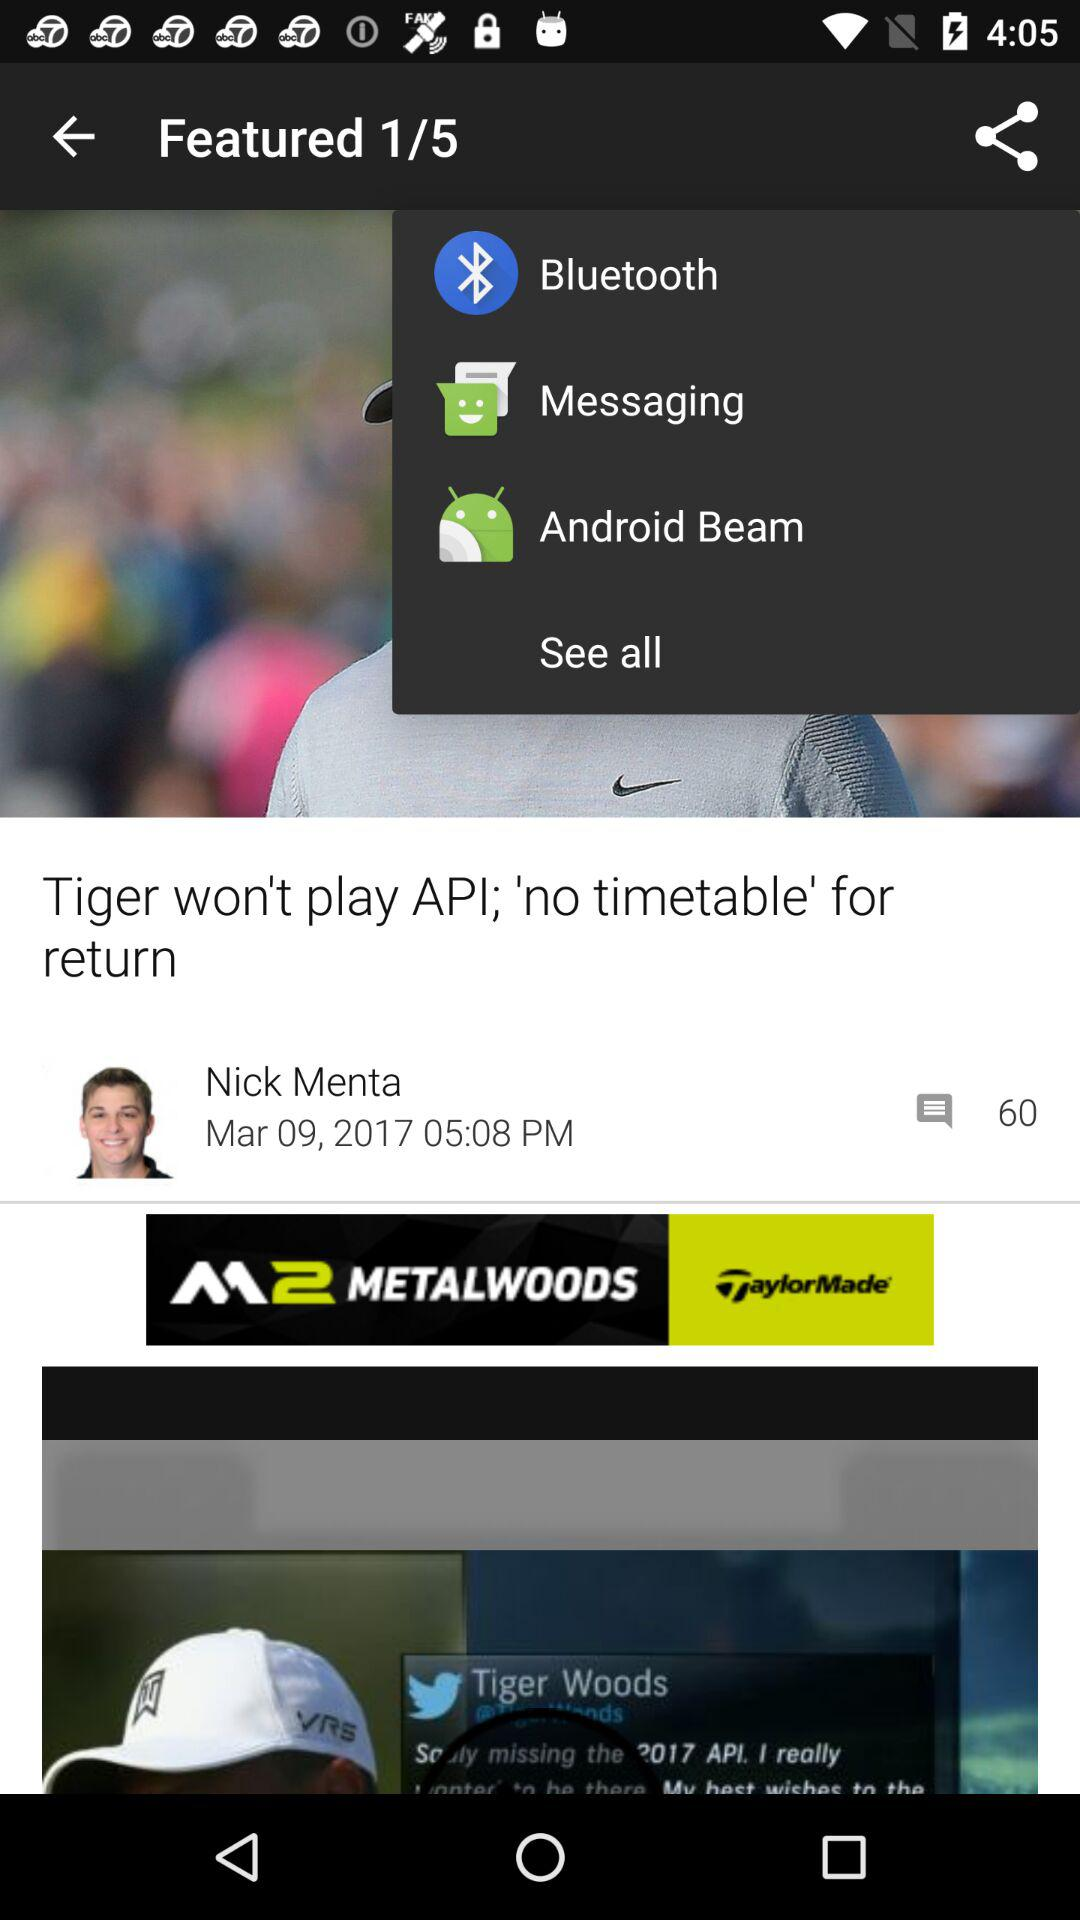What are all the sharing options?
When the provided information is insufficient, respond with <no answer>. <no answer> 